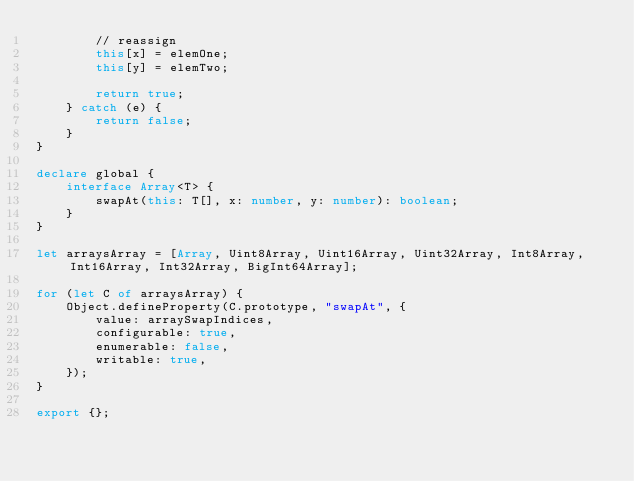<code> <loc_0><loc_0><loc_500><loc_500><_TypeScript_>        // reassign
        this[x] = elemOne;
        this[y] = elemTwo;

        return true;
    } catch (e) {
        return false;
    }
}

declare global {
    interface Array<T> {
        swapAt(this: T[], x: number, y: number): boolean;
    }
}

let arraysArray = [Array, Uint8Array, Uint16Array, Uint32Array, Int8Array, Int16Array, Int32Array, BigInt64Array];

for (let C of arraysArray) {
    Object.defineProperty(C.prototype, "swapAt", {
        value: arraySwapIndices,
        configurable: true,
        enumerable: false,
        writable: true,
    });
}

export {};</code> 